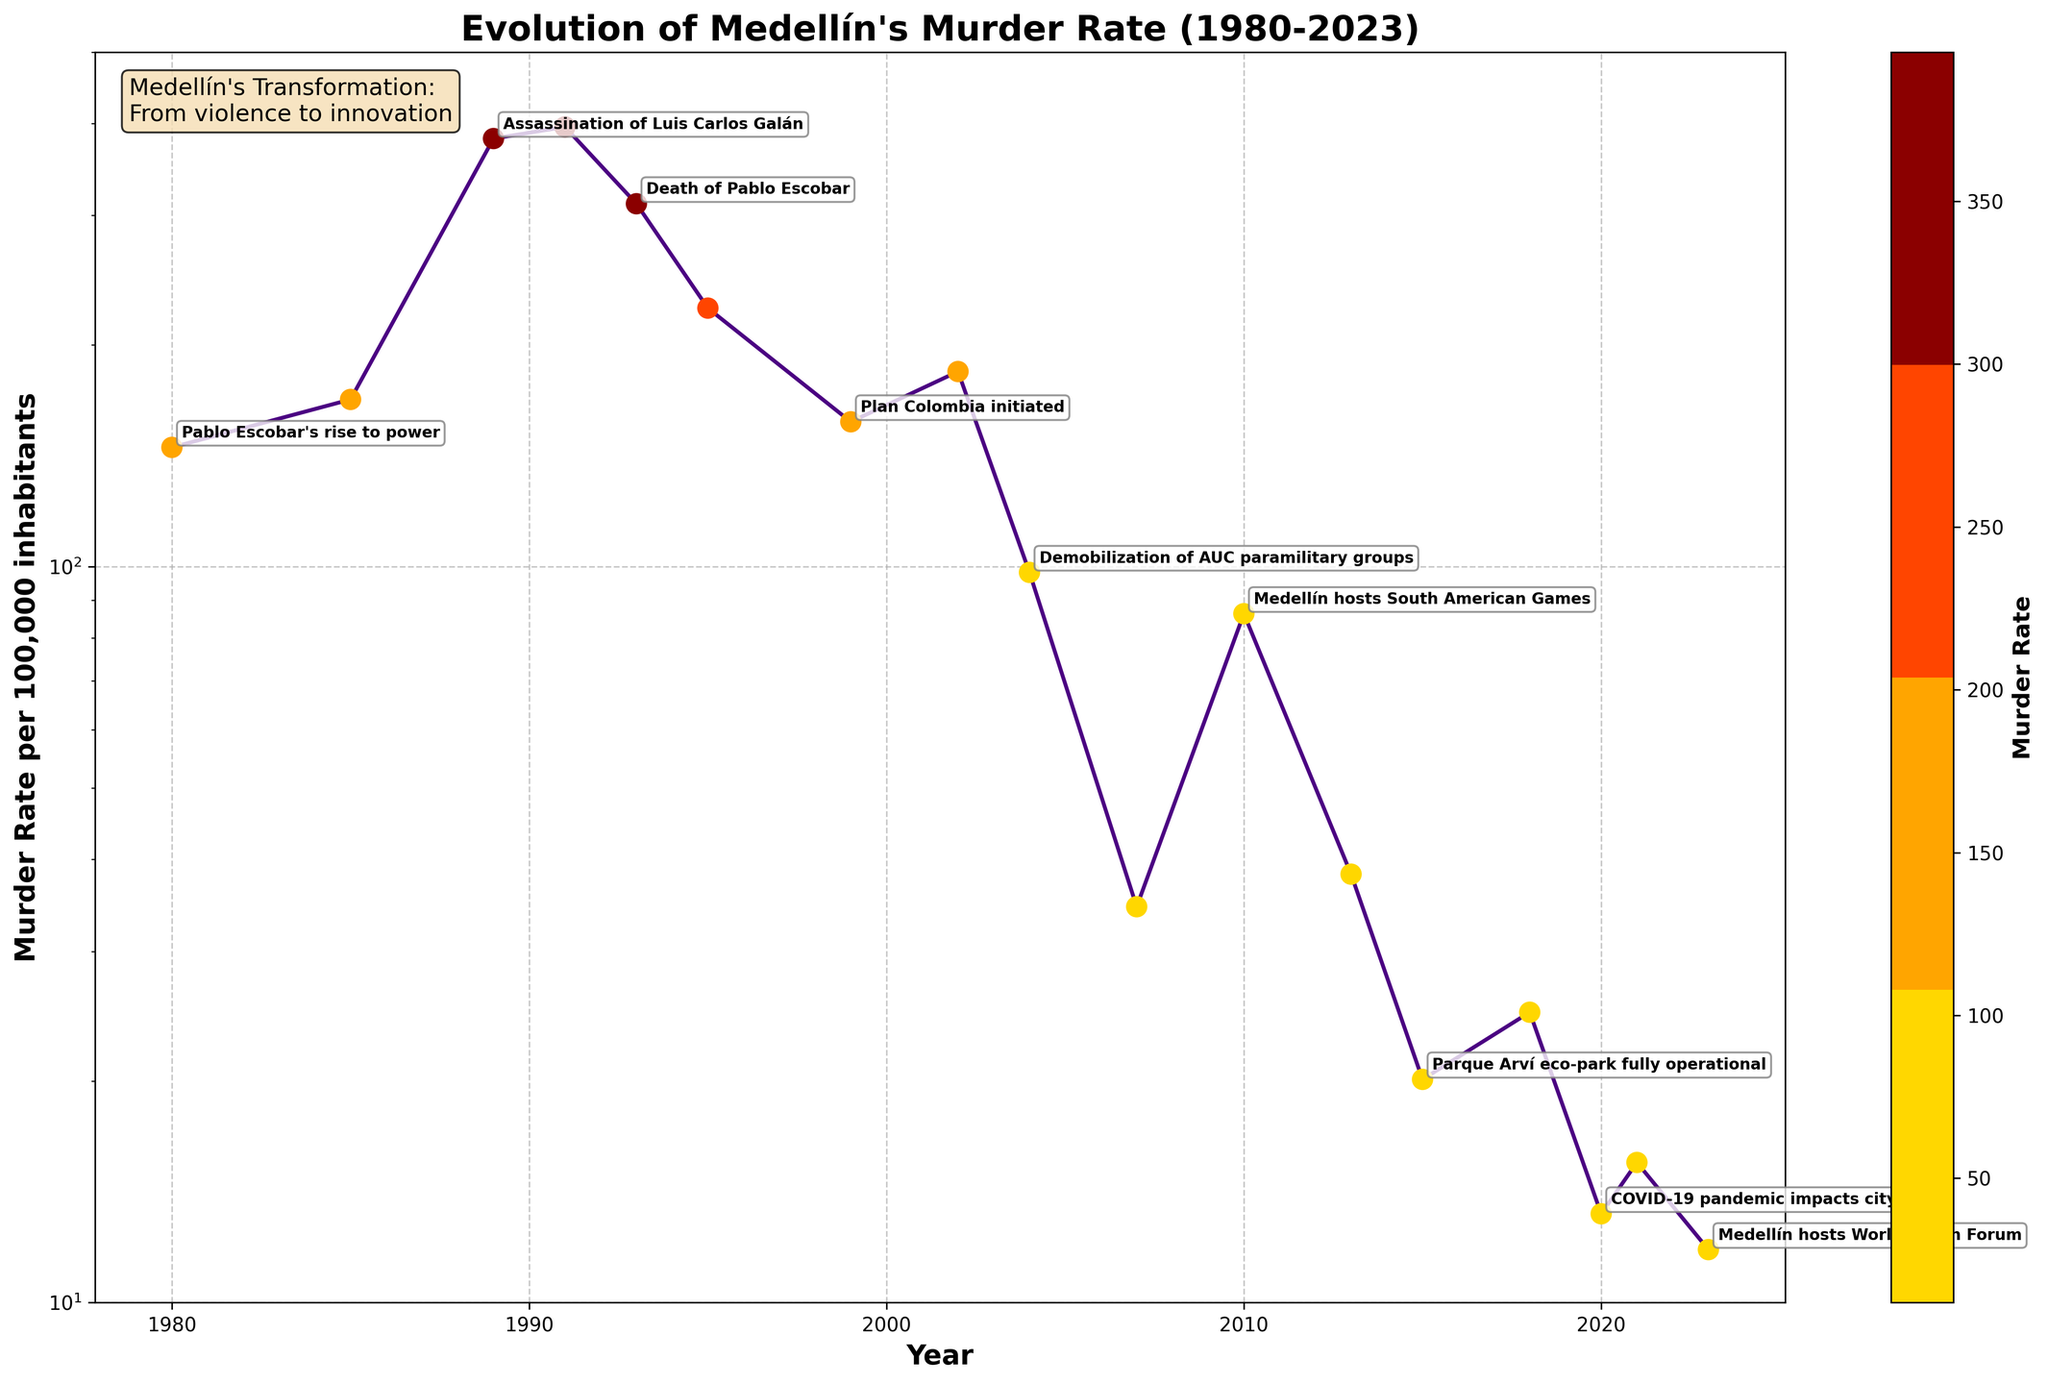What key historical event in Medellín coincided with the highest murder rate recorded in this dataset? From the chart, the highest murder rate per 100,000 inhabitants was recorded in 1991, which was coincident with the adoption of the new Colombian Constitution.
Answer: New Colombian Constitution What was the approximate decrease in the murder rate after the death of Pablo Escobar in 1993 up to the dismantling of the Cali Cartel in 1995? The murder rate in 1993 was 311.2, and in 1995 it was 224.5. So, the decrease is 311.2 - 224.5 = 86.7.
Answer: 86.7 Compare the murder rate in 1980 and 2023. Which year had a higher rate and by how much? In 1980, the murder rate was 145.2, and in 2023 it was 11.8. Therefore, the murder rate was higher in 1980 by 145.2 - 11.8 = 133.4.
Answer: 1980 by 133.4 What visual trend can you observe in Medellín's murder rate from 1991 to 2023? The murder rate steadily decreases from the peak in 1991 (395.8) to a much lower rate in 2023 (11.8).
Answer: Decreasing trend Which year had a greater murder rate, the one marked with the Metro Cable inauguration or the one with the Operation Orion? By how much? In 2007 (Metro Cable inauguration), the murder rate was 34.5, and in 2002 (Operation Orion), it was 184.1. The murder rate in 2002 was greater by 184.1 - 34.5 = 149.6.
Answer: 2002 by 149.6 Considering the murder rate in 1999 and the one in 2013, calculate the decrease over these years. In 1999, the murder rate was 157.3. In 2013, it was 38.2. The decrease is 157.3 - 38.2 = 119.1.
Answer: 119.1 What was the percentage reduction in the murder rate from 1991 to 2004? In 1991, the murder rate was 395.8. In 2004, it was 98.2. The reduction percentage is ((395.8 - 98.2) / 395.8) * 100% = 75.2%.
Answer: 75.2% How did the murder rate change from the start of Plan Colombia in 1999 to the COVID-19 pandemic in 2020? In 1999, the murder rate was 157.3. In 2020, it was 13.2. The change is a decrease of 157.3 - 13.2 = 144.1.
Answer: Decreased by 144.1 What event is associated with a drastic reduction in the murder rate around 2004, and how does it link to the observed reduction? The drastic reduction around 2004 is associated with the demobilization of AUC paramilitary groups, leading to a drop from 184.1 in 2002 to 98.2 in 2004.
Answer: Demobilization of AUC paramilitary groups What general pattern can you deduce about the murder rate in Medellín after key infrastructure projects like the Metro Cable system and Parque Arví eco-park were completed? After the completion of the Metro Cable system in 2007 and Parque Arví eco-park in 2015, the murder rate shows a significant downward trend.
Answer: Downward trend 